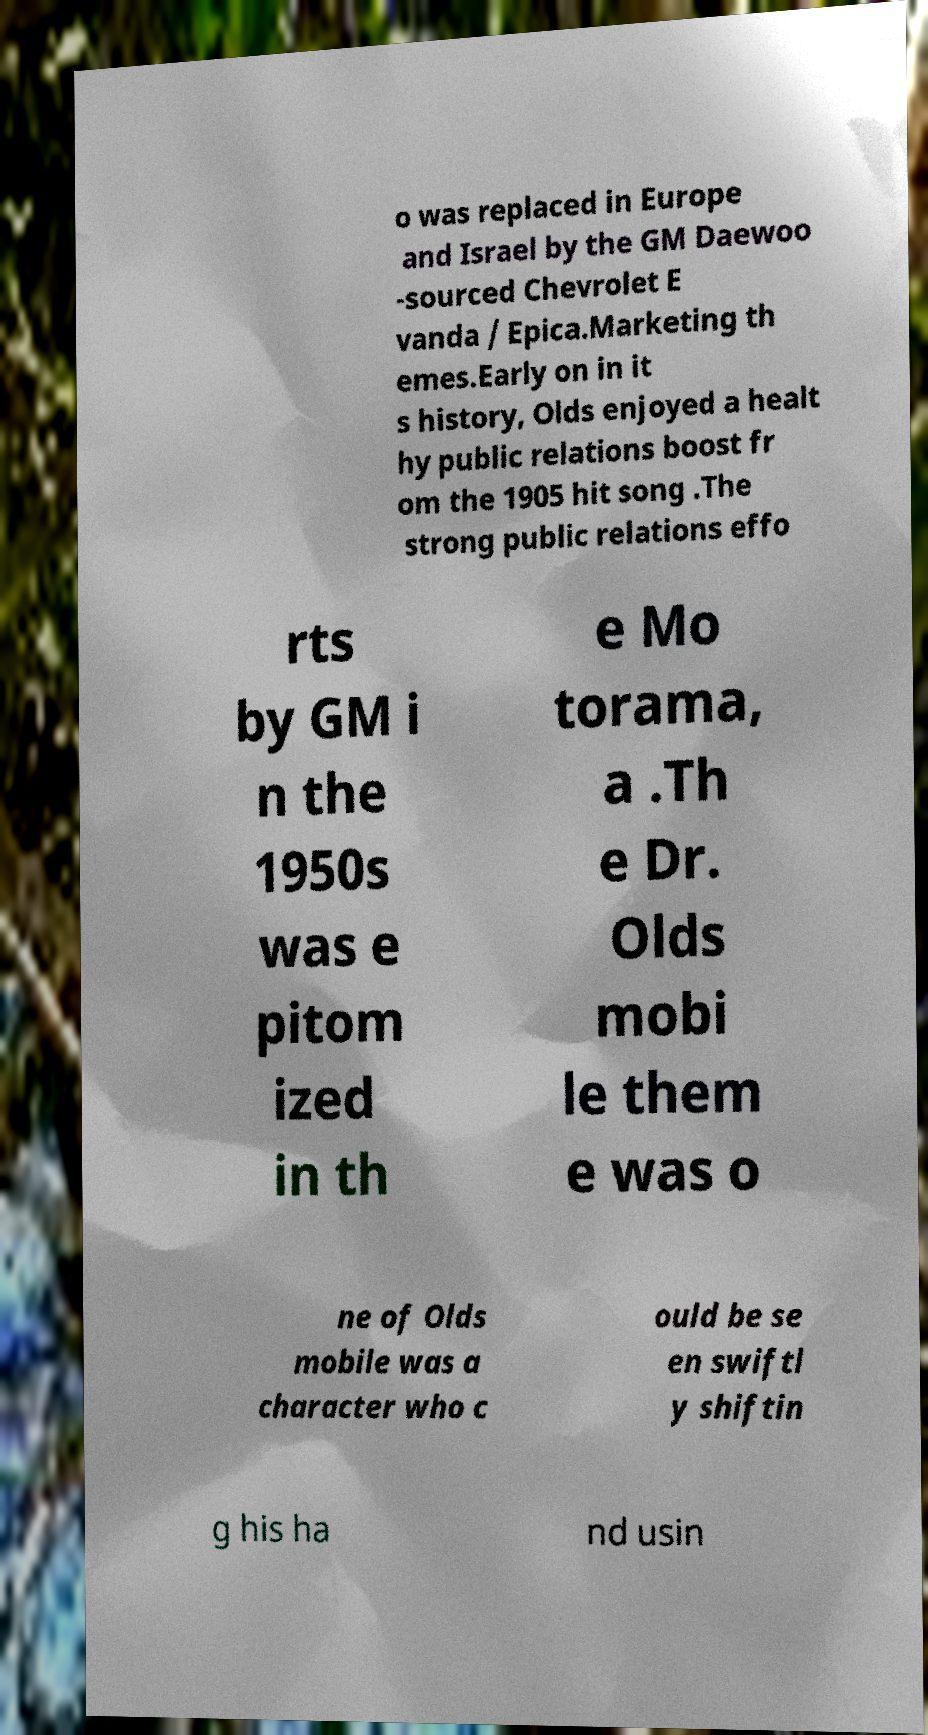Can you accurately transcribe the text from the provided image for me? o was replaced in Europe and Israel by the GM Daewoo -sourced Chevrolet E vanda / Epica.Marketing th emes.Early on in it s history, Olds enjoyed a healt hy public relations boost fr om the 1905 hit song .The strong public relations effo rts by GM i n the 1950s was e pitom ized in th e Mo torama, a .Th e Dr. Olds mobi le them e was o ne of Olds mobile was a character who c ould be se en swiftl y shiftin g his ha nd usin 